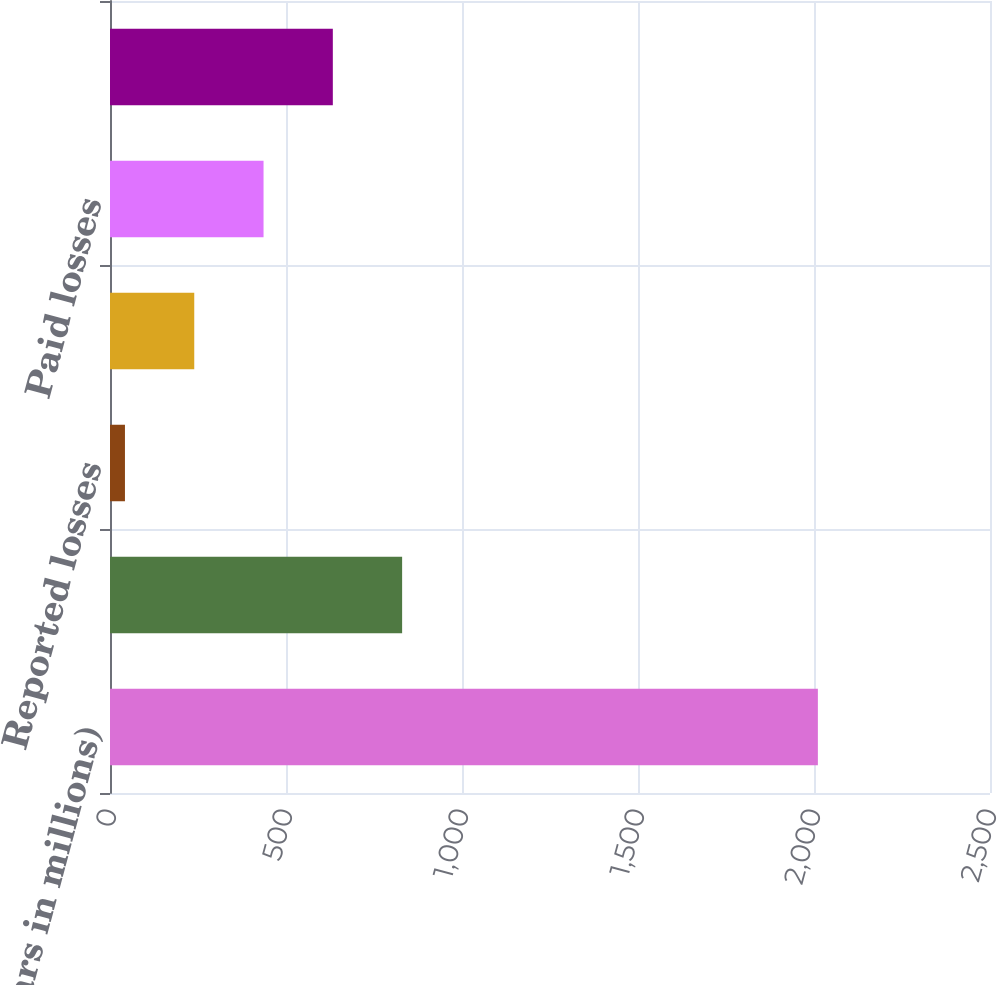Convert chart to OTSL. <chart><loc_0><loc_0><loc_500><loc_500><bar_chart><fcel>(Dollars in millions)<fcel>Beginning of period reserves<fcel>Reported losses<fcel>Change in IBNR<fcel>Paid losses<fcel>End of period reserves<nl><fcel>2011<fcel>829.9<fcel>42.5<fcel>239.35<fcel>436.2<fcel>633.05<nl></chart> 